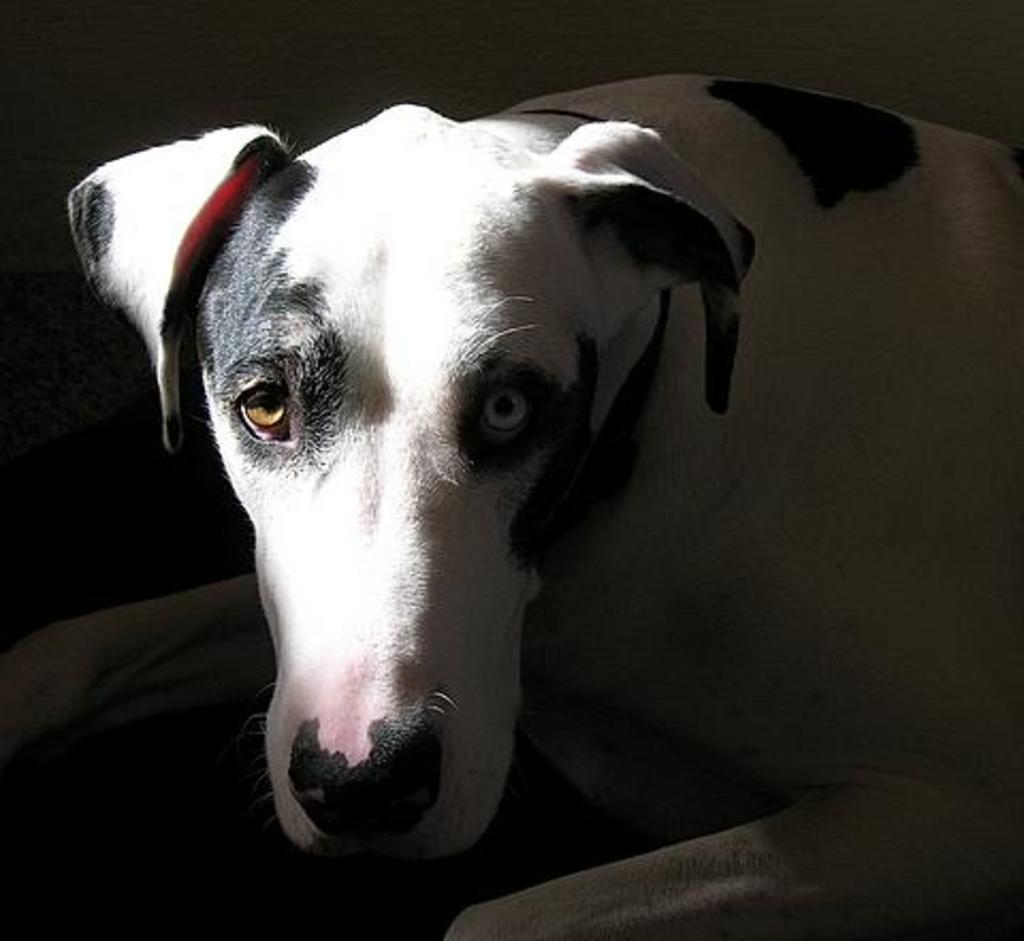Describe this image in one or two sentences. In this image there is a dog. 